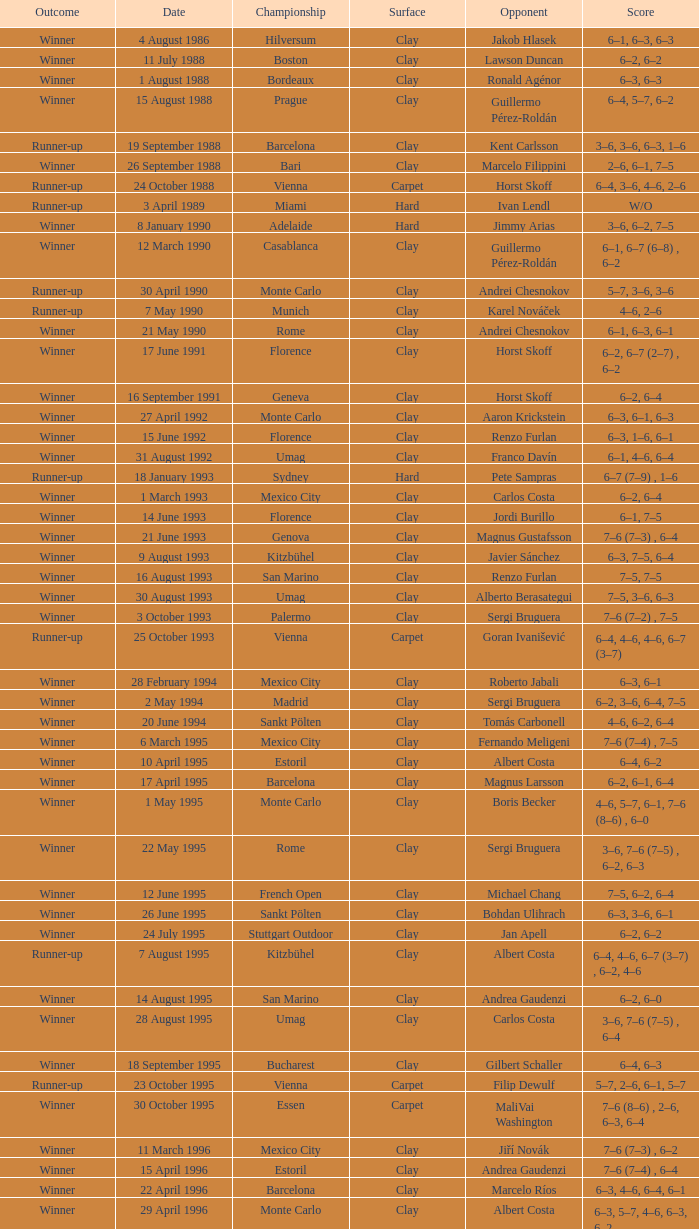What is the score when the championship is rome and the opponent is richard krajicek? 6–2, 6–4, 3–6, 6–3. 